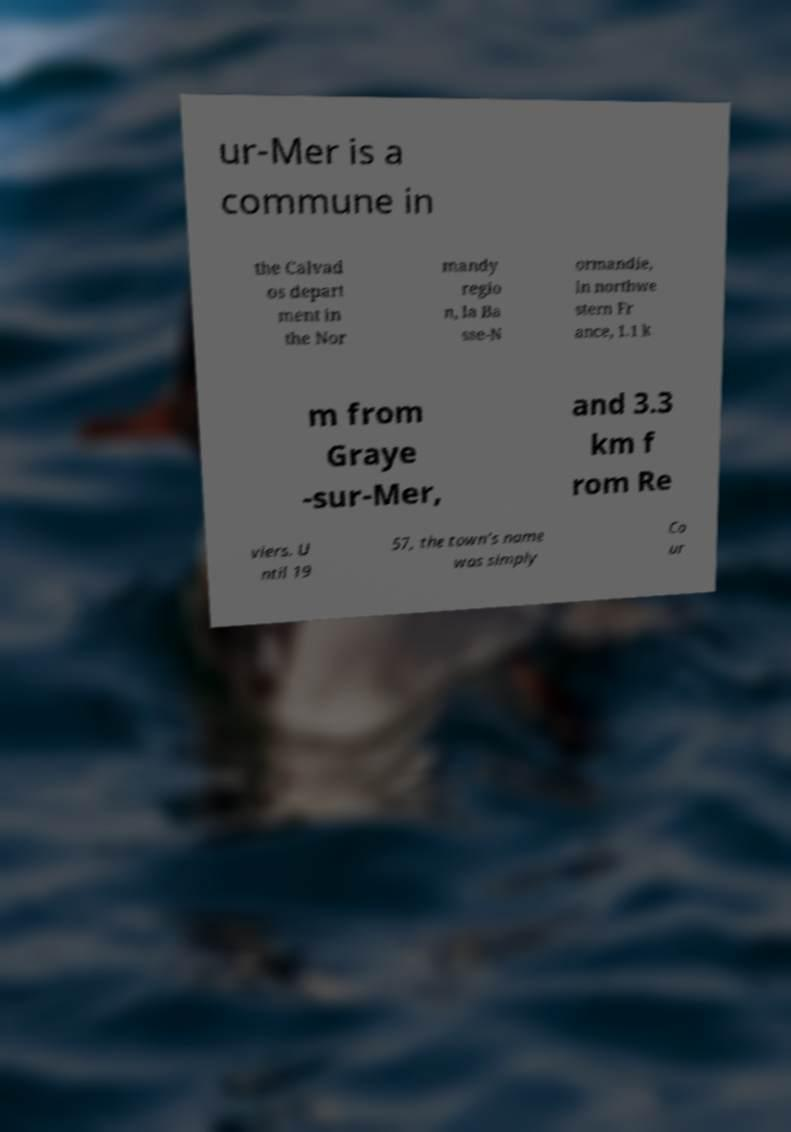I need the written content from this picture converted into text. Can you do that? ur-Mer is a commune in the Calvad os depart ment in the Nor mandy regio n, la Ba sse-N ormandie, in northwe stern Fr ance, 1.1 k m from Graye -sur-Mer, and 3.3 km f rom Re viers. U ntil 19 57, the town's name was simply Co ur 